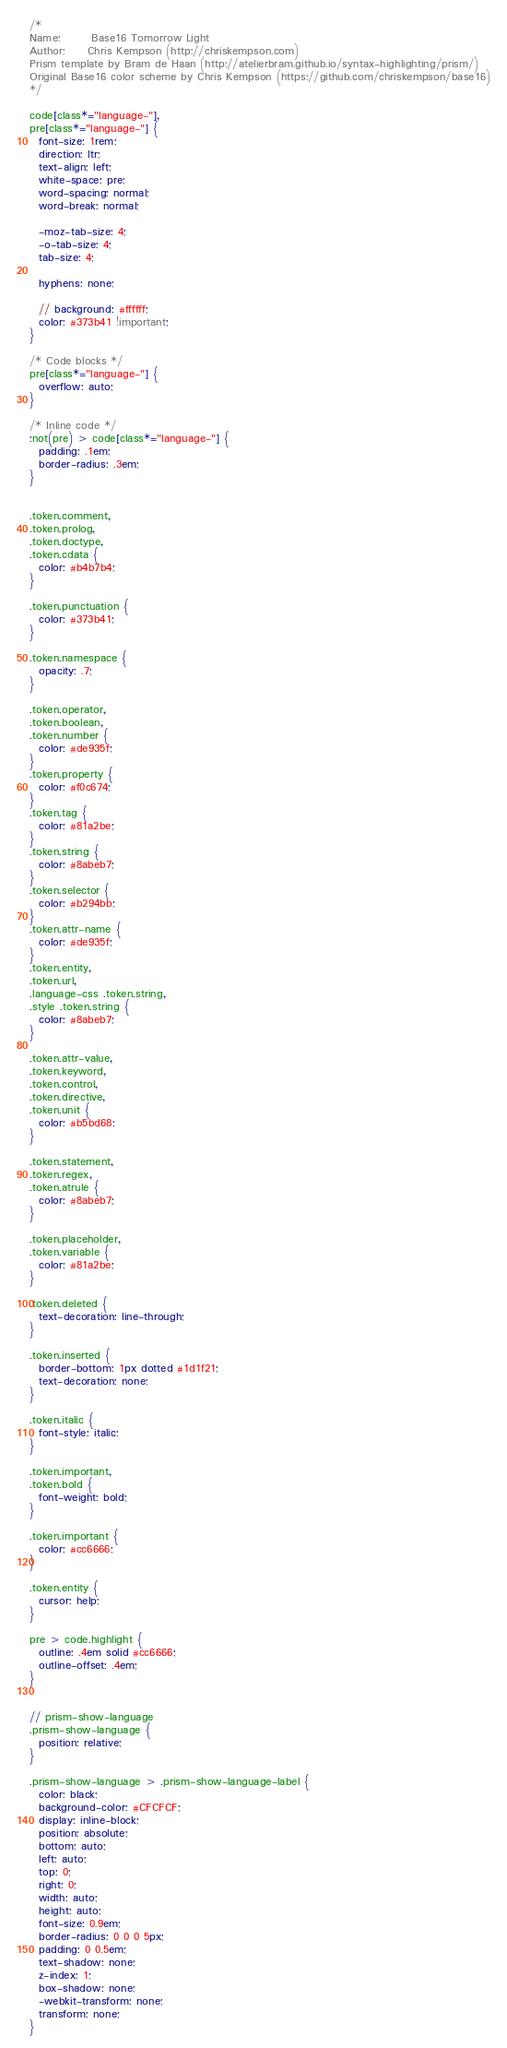<code> <loc_0><loc_0><loc_500><loc_500><_CSS_>/*
Name:       Base16 Tomorrow Light
Author:     Chris Kempson (http://chriskempson.com)
Prism template by Bram de Haan (http://atelierbram.github.io/syntax-highlighting/prism/)
Original Base16 color scheme by Chris Kempson (https://github.com/chriskempson/base16)
*/

code[class*="language-"],
pre[class*="language-"] {
  font-size: 1rem;
  direction: ltr;
  text-align: left;
  white-space: pre;
  word-spacing: normal;
  word-break: normal;

  -moz-tab-size: 4;
  -o-tab-size: 4;
  tab-size: 4;

  hyphens: none;

  // background: #ffffff;
  color: #373b41 !important;
}

/* Code blocks */
pre[class*="language-"] {
  overflow: auto;
}

/* Inline code */
:not(pre) > code[class*="language-"] {
  padding: .1em;
  border-radius: .3em;
}


.token.comment,
.token.prolog,
.token.doctype,
.token.cdata {
  color: #b4b7b4;
}

.token.punctuation {
  color: #373b41;
}

.token.namespace {
  opacity: .7;
}

.token.operator,
.token.boolean,
.token.number {
  color: #de935f;
}
.token.property {
  color: #f0c674;
}
.token.tag {
  color: #81a2be;
}
.token.string {
  color: #8abeb7;
}
.token.selector {
  color: #b294bb;
}
.token.attr-name {
  color: #de935f;
}
.token.entity,
.token.url,
.language-css .token.string,
.style .token.string {
  color: #8abeb7;
}

.token.attr-value,
.token.keyword,
.token.control,
.token.directive,
.token.unit {
  color: #b5bd68;
}

.token.statement,
.token.regex,
.token.atrule {
  color: #8abeb7;
}

.token.placeholder,
.token.variable {
  color: #81a2be;
}

.token.deleted {
  text-decoration: line-through;
}

.token.inserted {
  border-bottom: 1px dotted #1d1f21;
  text-decoration: none;
}

.token.italic {
  font-style: italic;
}

.token.important,
.token.bold {
  font-weight: bold;
}

.token.important {
  color: #cc6666;
}

.token.entity {
  cursor: help;
}

pre > code.highlight {
  outline: .4em solid #cc6666;
  outline-offset: .4em;
}


// prism-show-language
.prism-show-language {
  position: relative;
}

.prism-show-language > .prism-show-language-label {
  color: black;
  background-color: #CFCFCF;
  display: inline-block;
  position: absolute;
  bottom: auto;
  left: auto;
  top: 0;
  right: 0;
  width: auto;
  height: auto;
  font-size: 0.9em;
  border-radius: 0 0 0 5px;
  padding: 0 0.5em;
  text-shadow: none;
  z-index: 1;
  box-shadow: none;
  -webkit-transform: none;
  transform: none;
}
</code> 